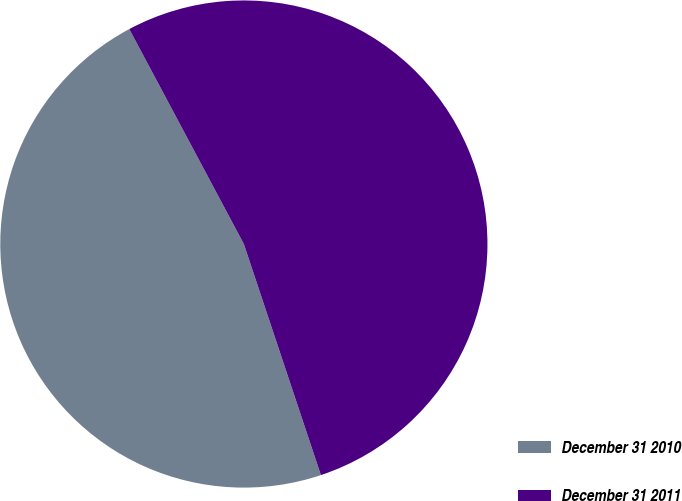<chart> <loc_0><loc_0><loc_500><loc_500><pie_chart><fcel>December 31 2010<fcel>December 31 2011<nl><fcel>47.33%<fcel>52.67%<nl></chart> 